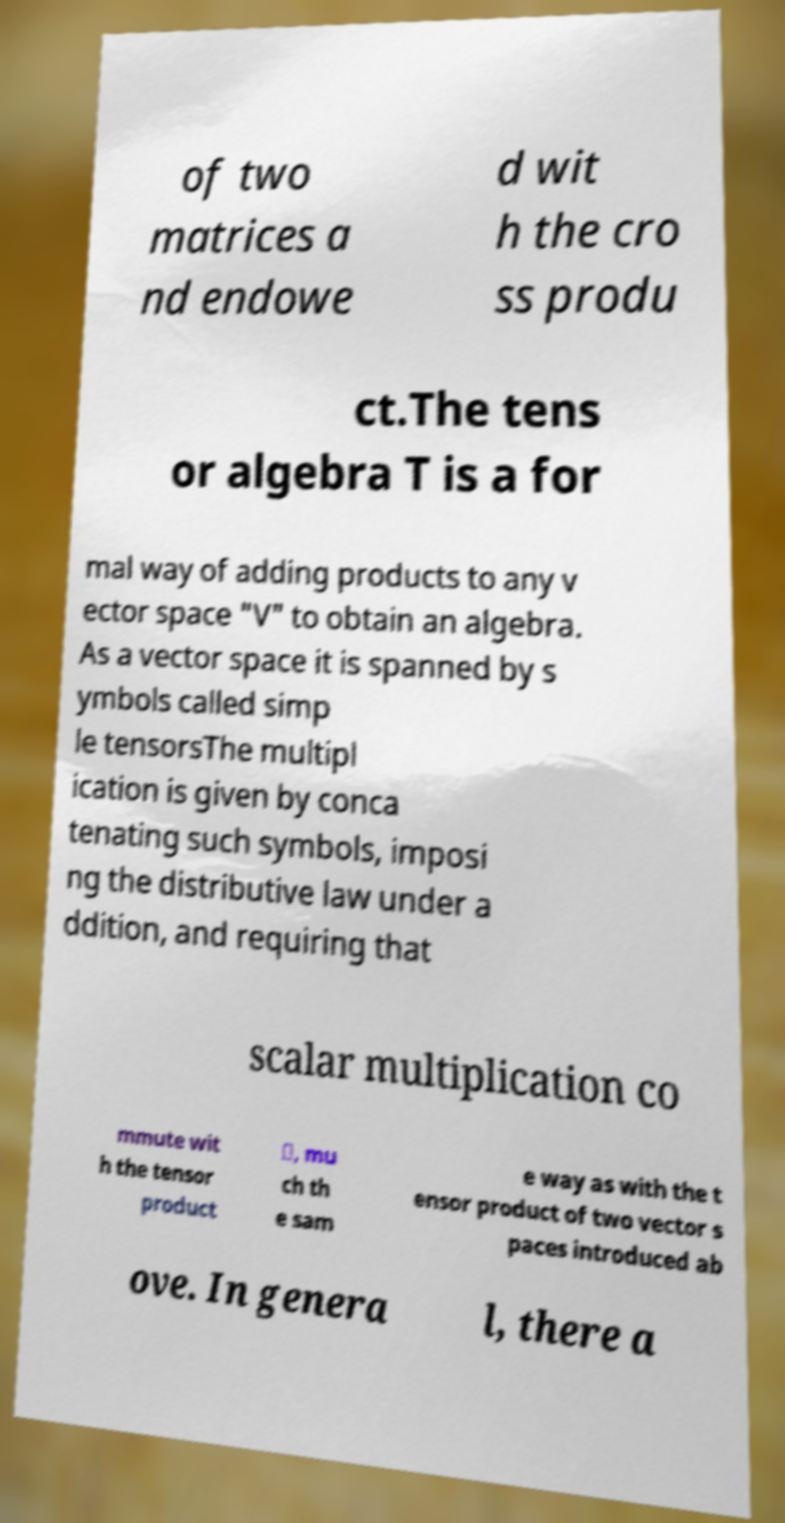For documentation purposes, I need the text within this image transcribed. Could you provide that? of two matrices a nd endowe d wit h the cro ss produ ct.The tens or algebra T is a for mal way of adding products to any v ector space "V" to obtain an algebra. As a vector space it is spanned by s ymbols called simp le tensorsThe multipl ication is given by conca tenating such symbols, imposi ng the distributive law under a ddition, and requiring that scalar multiplication co mmute wit h the tensor product ⊗, mu ch th e sam e way as with the t ensor product of two vector s paces introduced ab ove. In genera l, there a 